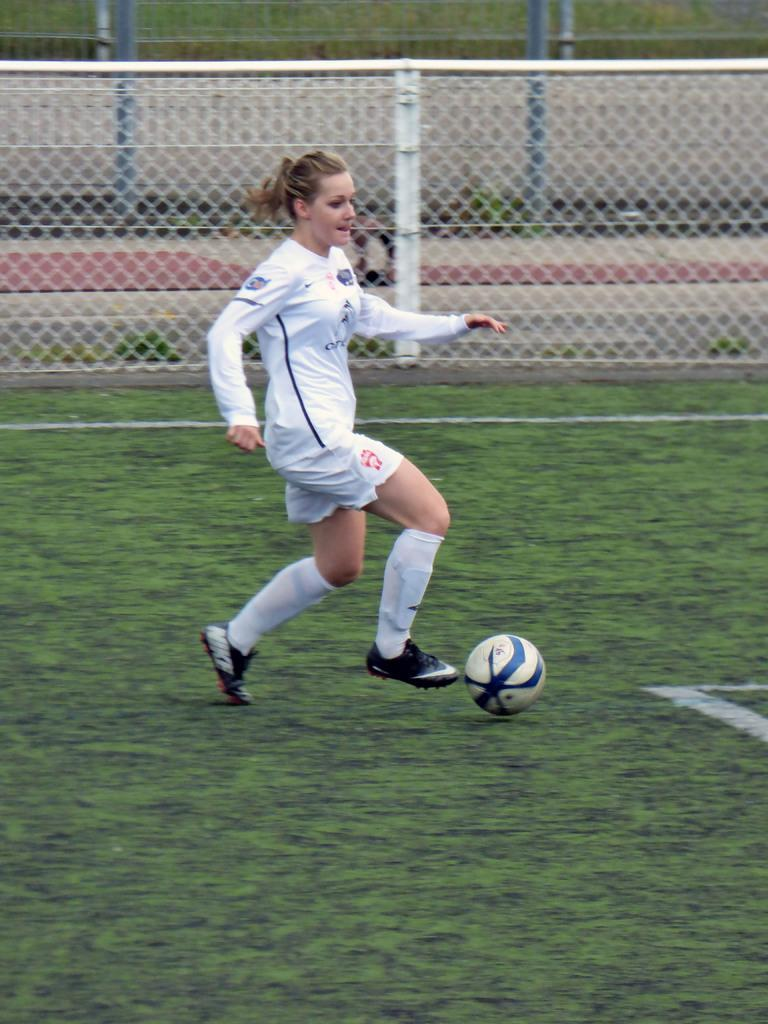What is the main subject of the image? There is a woman football player in the image. What is the woman football player doing in the image? The woman is kicking a ball. Can you describe the context of the image? The scene appears to be from a match. How much wealth does the woman football player have in the image? There is no information about the woman football player's wealth in the image. What arithmetic problem is the woman football player solving in the image? There is no arithmetic problem present in the image; the woman is focused on kicking a ball. 